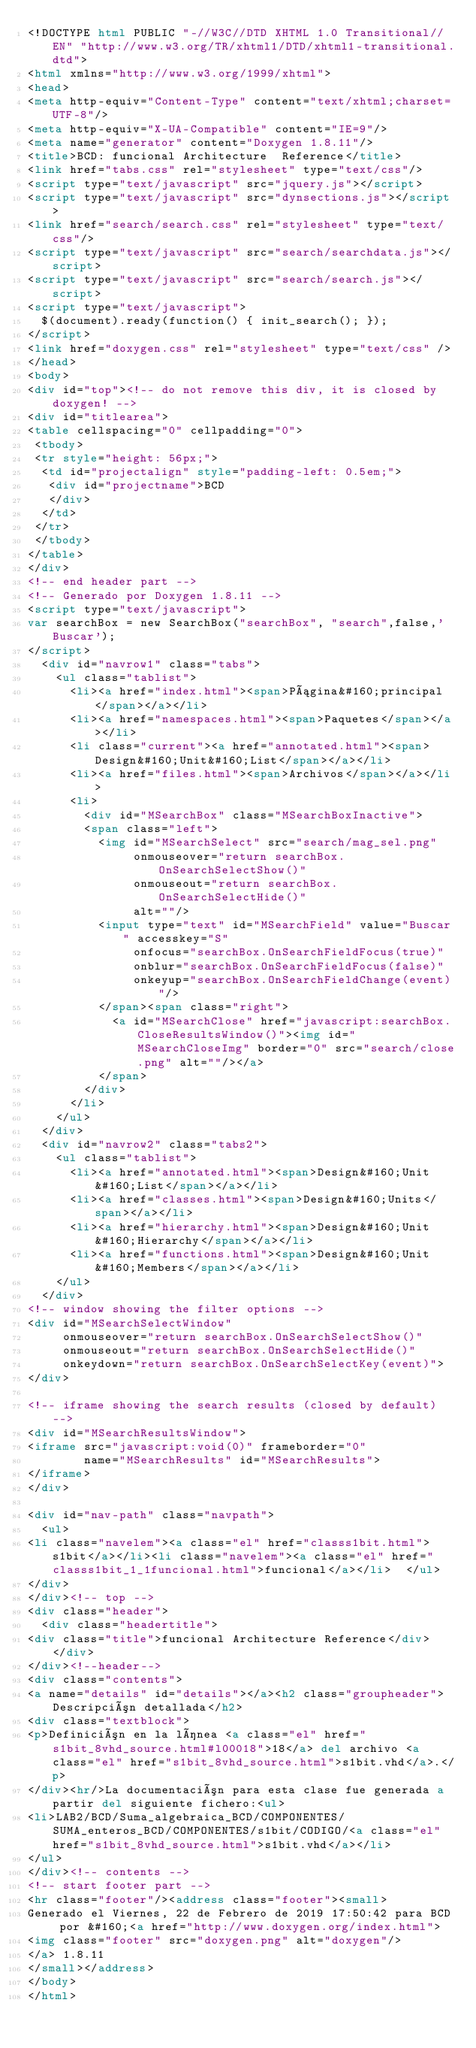<code> <loc_0><loc_0><loc_500><loc_500><_HTML_><!DOCTYPE html PUBLIC "-//W3C//DTD XHTML 1.0 Transitional//EN" "http://www.w3.org/TR/xhtml1/DTD/xhtml1-transitional.dtd">
<html xmlns="http://www.w3.org/1999/xhtml">
<head>
<meta http-equiv="Content-Type" content="text/xhtml;charset=UTF-8"/>
<meta http-equiv="X-UA-Compatible" content="IE=9"/>
<meta name="generator" content="Doxygen 1.8.11"/>
<title>BCD: funcional Architecture  Reference</title>
<link href="tabs.css" rel="stylesheet" type="text/css"/>
<script type="text/javascript" src="jquery.js"></script>
<script type="text/javascript" src="dynsections.js"></script>
<link href="search/search.css" rel="stylesheet" type="text/css"/>
<script type="text/javascript" src="search/searchdata.js"></script>
<script type="text/javascript" src="search/search.js"></script>
<script type="text/javascript">
  $(document).ready(function() { init_search(); });
</script>
<link href="doxygen.css" rel="stylesheet" type="text/css" />
</head>
<body>
<div id="top"><!-- do not remove this div, it is closed by doxygen! -->
<div id="titlearea">
<table cellspacing="0" cellpadding="0">
 <tbody>
 <tr style="height: 56px;">
  <td id="projectalign" style="padding-left: 0.5em;">
   <div id="projectname">BCD
   </div>
  </td>
 </tr>
 </tbody>
</table>
</div>
<!-- end header part -->
<!-- Generado por Doxygen 1.8.11 -->
<script type="text/javascript">
var searchBox = new SearchBox("searchBox", "search",false,'Buscar');
</script>
  <div id="navrow1" class="tabs">
    <ul class="tablist">
      <li><a href="index.html"><span>Página&#160;principal</span></a></li>
      <li><a href="namespaces.html"><span>Paquetes</span></a></li>
      <li class="current"><a href="annotated.html"><span>Design&#160;Unit&#160;List</span></a></li>
      <li><a href="files.html"><span>Archivos</span></a></li>
      <li>
        <div id="MSearchBox" class="MSearchBoxInactive">
        <span class="left">
          <img id="MSearchSelect" src="search/mag_sel.png"
               onmouseover="return searchBox.OnSearchSelectShow()"
               onmouseout="return searchBox.OnSearchSelectHide()"
               alt=""/>
          <input type="text" id="MSearchField" value="Buscar" accesskey="S"
               onfocus="searchBox.OnSearchFieldFocus(true)" 
               onblur="searchBox.OnSearchFieldFocus(false)" 
               onkeyup="searchBox.OnSearchFieldChange(event)"/>
          </span><span class="right">
            <a id="MSearchClose" href="javascript:searchBox.CloseResultsWindow()"><img id="MSearchCloseImg" border="0" src="search/close.png" alt=""/></a>
          </span>
        </div>
      </li>
    </ul>
  </div>
  <div id="navrow2" class="tabs2">
    <ul class="tablist">
      <li><a href="annotated.html"><span>Design&#160;Unit&#160;List</span></a></li>
      <li><a href="classes.html"><span>Design&#160;Units</span></a></li>
      <li><a href="hierarchy.html"><span>Design&#160;Unit&#160;Hierarchy</span></a></li>
      <li><a href="functions.html"><span>Design&#160;Unit&#160;Members</span></a></li>
    </ul>
  </div>
<!-- window showing the filter options -->
<div id="MSearchSelectWindow"
     onmouseover="return searchBox.OnSearchSelectShow()"
     onmouseout="return searchBox.OnSearchSelectHide()"
     onkeydown="return searchBox.OnSearchSelectKey(event)">
</div>

<!-- iframe showing the search results (closed by default) -->
<div id="MSearchResultsWindow">
<iframe src="javascript:void(0)" frameborder="0" 
        name="MSearchResults" id="MSearchResults">
</iframe>
</div>

<div id="nav-path" class="navpath">
  <ul>
<li class="navelem"><a class="el" href="classs1bit.html">s1bit</a></li><li class="navelem"><a class="el" href="classs1bit_1_1funcional.html">funcional</a></li>  </ul>
</div>
</div><!-- top -->
<div class="header">
  <div class="headertitle">
<div class="title">funcional Architecture Reference</div>  </div>
</div><!--header-->
<div class="contents">
<a name="details" id="details"></a><h2 class="groupheader">Descripción detallada</h2>
<div class="textblock">
<p>Definición en la línea <a class="el" href="s1bit_8vhd_source.html#l00018">18</a> del archivo <a class="el" href="s1bit_8vhd_source.html">s1bit.vhd</a>.</p>
</div><hr/>La documentación para esta clase fue generada a partir del siguiente fichero:<ul>
<li>LAB2/BCD/Suma_algebraica_BCD/COMPONENTES/SUMA_enteros_BCD/COMPONENTES/s1bit/CODIGO/<a class="el" href="s1bit_8vhd_source.html">s1bit.vhd</a></li>
</ul>
</div><!-- contents -->
<!-- start footer part -->
<hr class="footer"/><address class="footer"><small>
Generado el Viernes, 22 de Febrero de 2019 17:50:42 para BCD por &#160;<a href="http://www.doxygen.org/index.html">
<img class="footer" src="doxygen.png" alt="doxygen"/>
</a> 1.8.11
</small></address>
</body>
</html>
</code> 